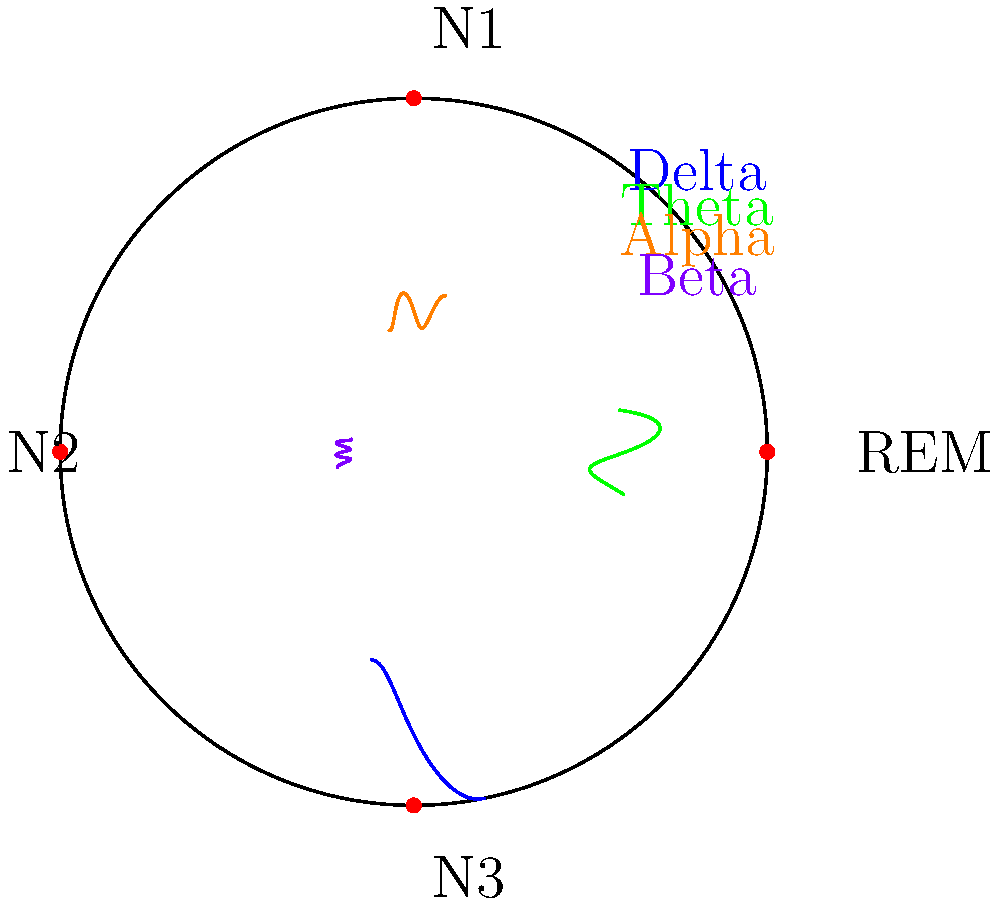In the polar graph representing different sleep stages and associated brain wave patterns, which brain wave is most prominent during the N3 (deep sleep) stage, and what is its typical frequency range? To answer this question, let's analyze the polar graph step-by-step:

1. The polar graph is divided into four quadrants, each representing a sleep stage: REM, N1, N2, and N3.

2. N3, also known as deep sleep or slow-wave sleep, is located in the bottom-left quadrant of the graph (3π/2 position).

3. Four different brain wave patterns are shown on the graph: Delta (blue), Theta (green), Alpha (orange), and Beta (purple).

4. In the N3 quadrant, we can see that the blue wave pattern is the most prominent, extending further from the center than the other wave patterns.

5. The blue wave pattern represents Delta waves, which are characteristic of deep sleep (N3 stage).

6. Delta waves typically have a frequency range of 0.5-4 Hz, which is the slowest of all brain wave patterns.

Therefore, the brain wave most prominent during the N3 (deep sleep) stage is the Delta wave, with a typical frequency range of 0.5-4 Hz.
Answer: Delta waves, 0.5-4 Hz 